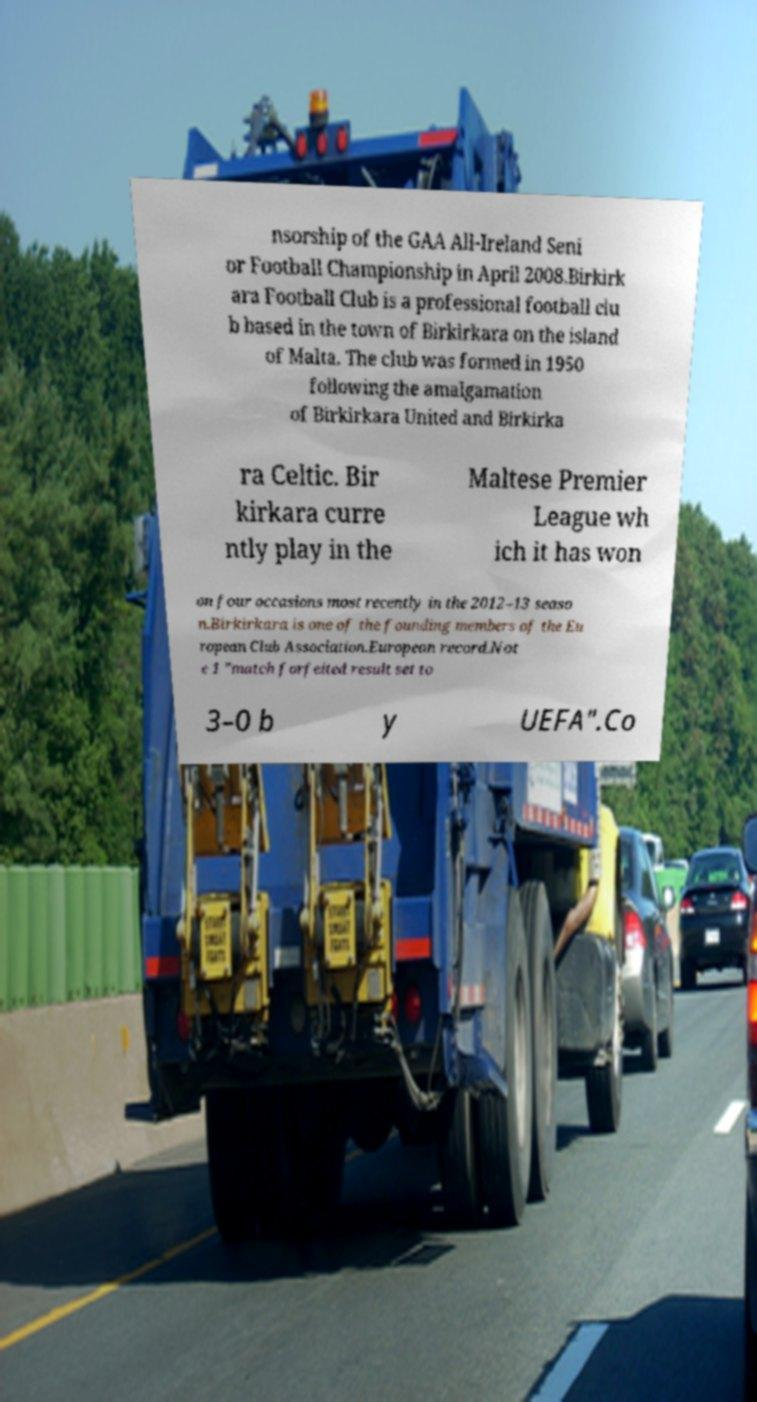I need the written content from this picture converted into text. Can you do that? nsorship of the GAA All-Ireland Seni or Football Championship in April 2008.Birkirk ara Football Club is a professional football clu b based in the town of Birkirkara on the island of Malta. The club was formed in 1950 following the amalgamation of Birkirkara United and Birkirka ra Celtic. Bir kirkara curre ntly play in the Maltese Premier League wh ich it has won on four occasions most recently in the 2012–13 seaso n.Birkirkara is one of the founding members of the Eu ropean Club Association.European record.Not e 1 "match forfeited result set to 3–0 b y UEFA".Co 